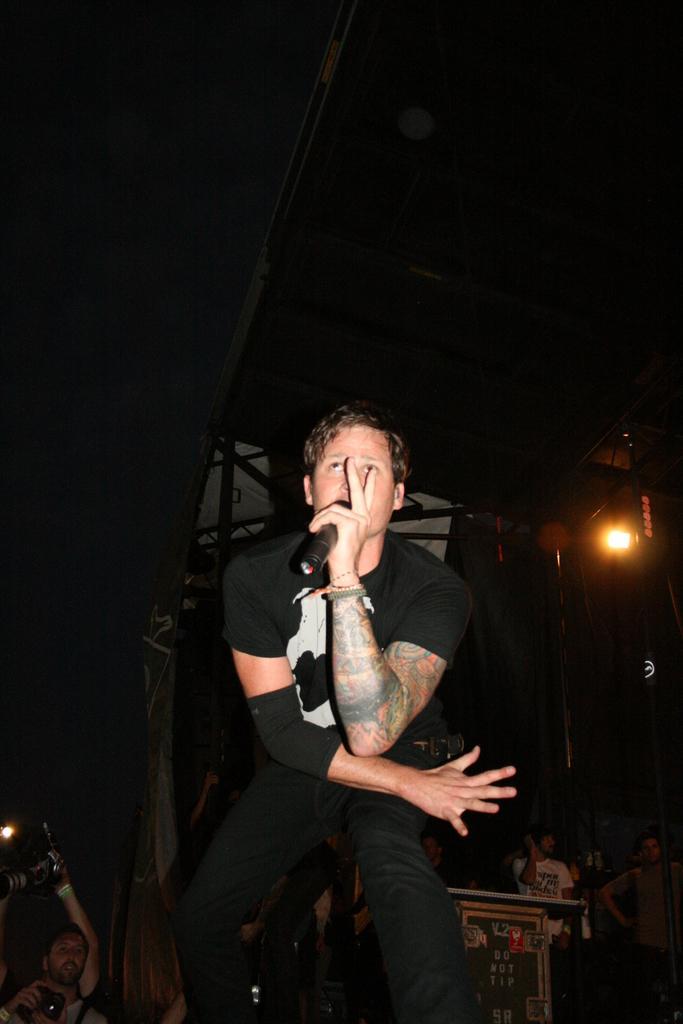Could you give a brief overview of what you see in this image? In this image there is a man sitting in the chair and holding a micro phone and in back ground we have lights , and some group of people standing. 